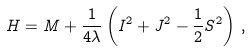<formula> <loc_0><loc_0><loc_500><loc_500>H = M + \frac { 1 } { 4 \lambda } \left ( I ^ { 2 } + J ^ { 2 } - \frac { 1 } { 2 } S ^ { 2 } \right ) \, ,</formula> 